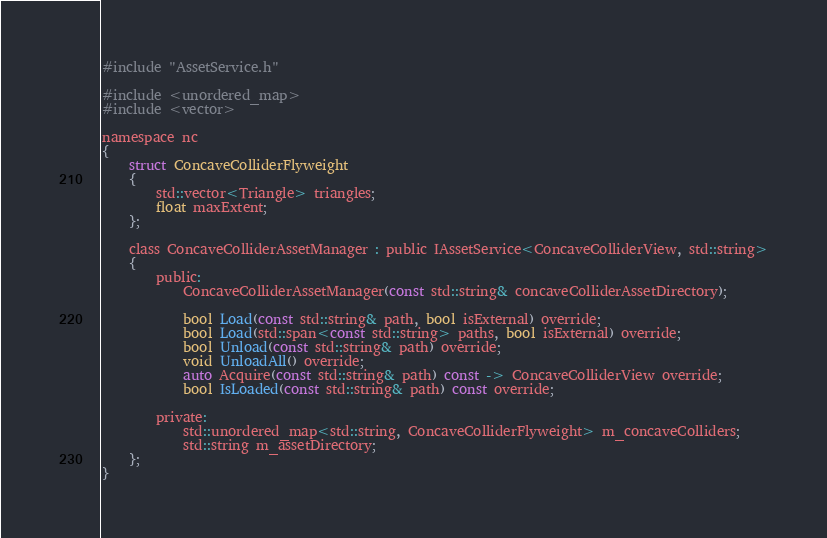Convert code to text. <code><loc_0><loc_0><loc_500><loc_500><_C_>
#include "AssetService.h"

#include <unordered_map>
#include <vector>

namespace nc
{
    struct ConcaveColliderFlyweight
    {
        std::vector<Triangle> triangles;
        float maxExtent;
    };

    class ConcaveColliderAssetManager : public IAssetService<ConcaveColliderView, std::string>
    {
        public:
            ConcaveColliderAssetManager(const std::string& concaveColliderAssetDirectory);

            bool Load(const std::string& path, bool isExternal) override;
            bool Load(std::span<const std::string> paths, bool isExternal) override;
            bool Unload(const std::string& path) override;
            void UnloadAll() override;
            auto Acquire(const std::string& path) const -> ConcaveColliderView override;
            bool IsLoaded(const std::string& path) const override;
        
        private:
            std::unordered_map<std::string, ConcaveColliderFlyweight> m_concaveColliders;
            std::string m_assetDirectory;
    };
}</code> 